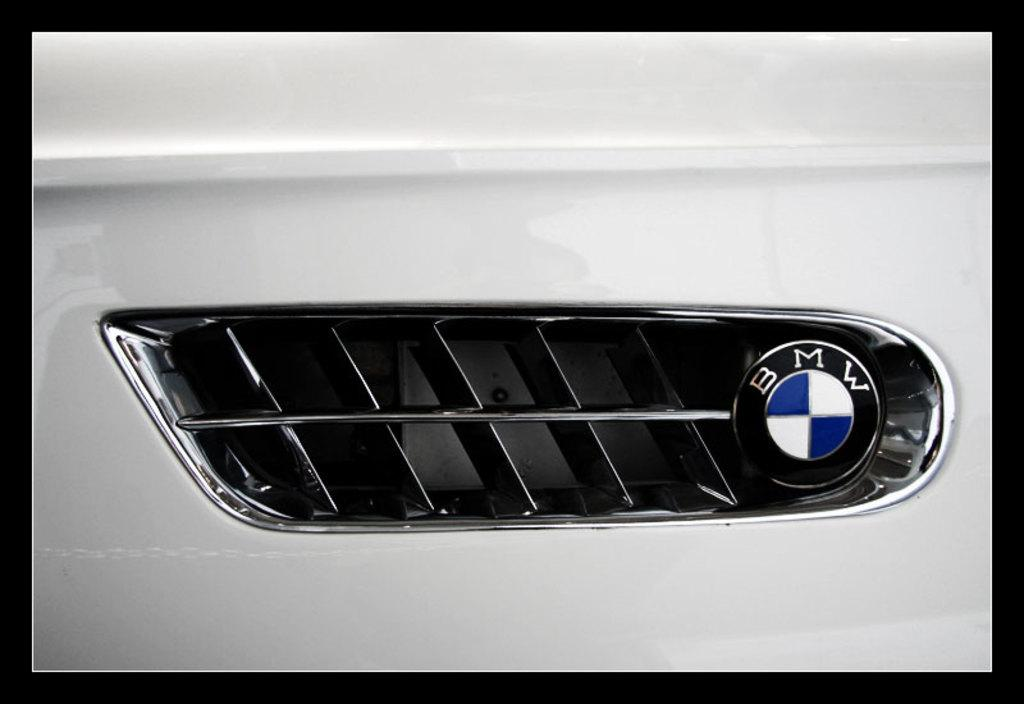What part of the car is visible in the picture? There is a side grill of a car in the picture. What is present on the side grill of the car? There is a logo on the car's side grill. What can be seen on the logo? The logo has something written on it. What colors are used in the logo? The logo has a white and blue color scheme. What type of animal can be seen performing on the stage in the image? There is no stage or animal present in the image; it features a car's side grill with a logo. 